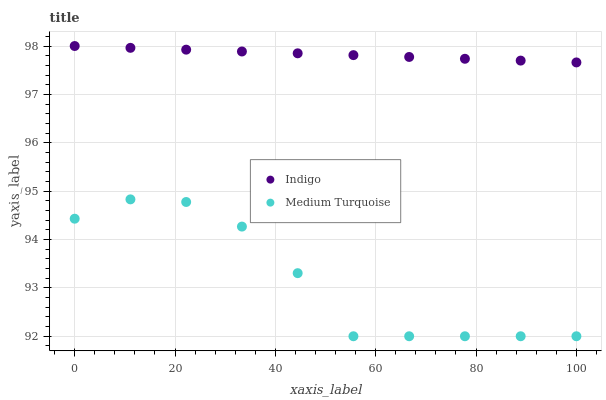Does Medium Turquoise have the minimum area under the curve?
Answer yes or no. Yes. Does Indigo have the maximum area under the curve?
Answer yes or no. Yes. Does Medium Turquoise have the maximum area under the curve?
Answer yes or no. No. Is Indigo the smoothest?
Answer yes or no. Yes. Is Medium Turquoise the roughest?
Answer yes or no. Yes. Is Medium Turquoise the smoothest?
Answer yes or no. No. Does Medium Turquoise have the lowest value?
Answer yes or no. Yes. Does Indigo have the highest value?
Answer yes or no. Yes. Does Medium Turquoise have the highest value?
Answer yes or no. No. Is Medium Turquoise less than Indigo?
Answer yes or no. Yes. Is Indigo greater than Medium Turquoise?
Answer yes or no. Yes. Does Medium Turquoise intersect Indigo?
Answer yes or no. No. 